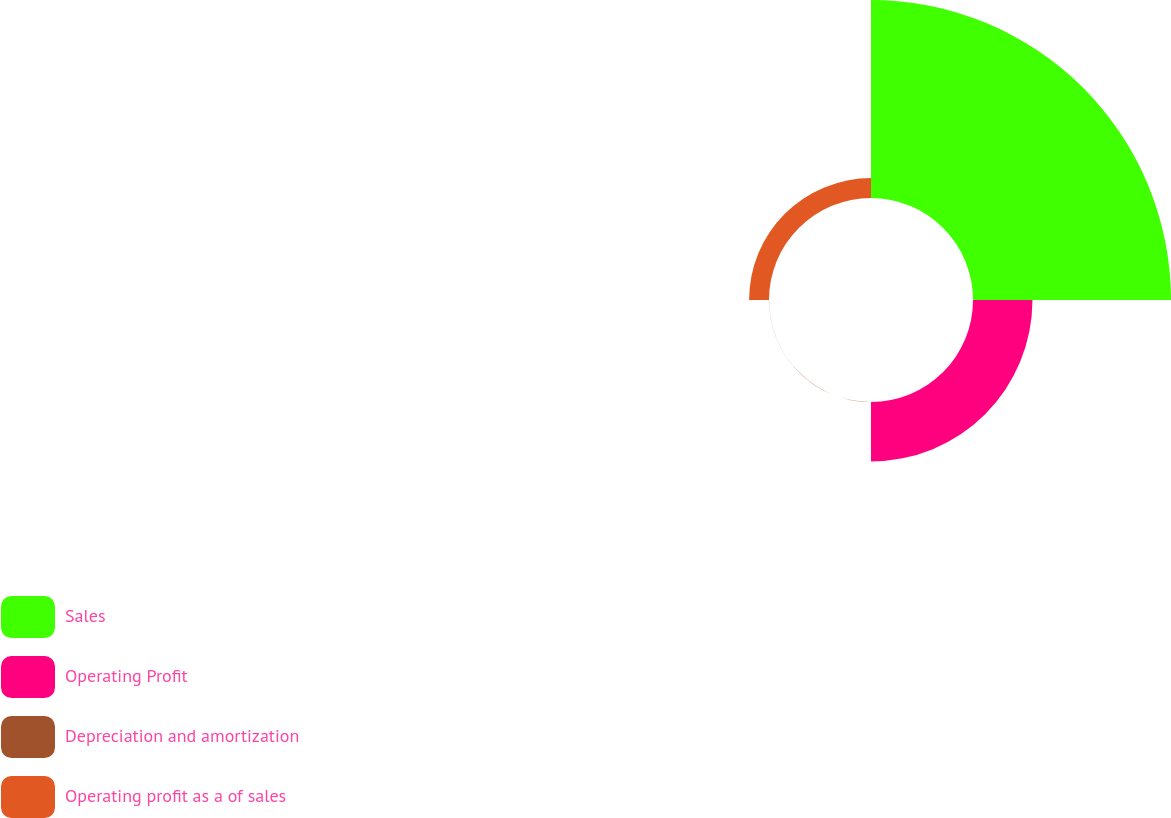Convert chart. <chart><loc_0><loc_0><loc_500><loc_500><pie_chart><fcel>Sales<fcel>Operating Profit<fcel>Depreciation and amortization<fcel>Operating profit as a of sales<nl><fcel>71.36%<fcel>21.43%<fcel>0.04%<fcel>7.17%<nl></chart> 